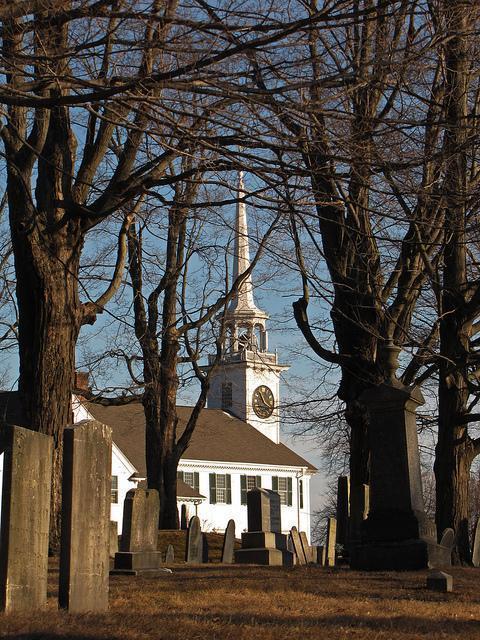How many people are here?
Give a very brief answer. 0. 